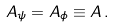Convert formula to latex. <formula><loc_0><loc_0><loc_500><loc_500>A _ { \psi } = A _ { \phi } \equiv A \, .</formula> 